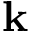<formula> <loc_0><loc_0><loc_500><loc_500>{ k }</formula> 